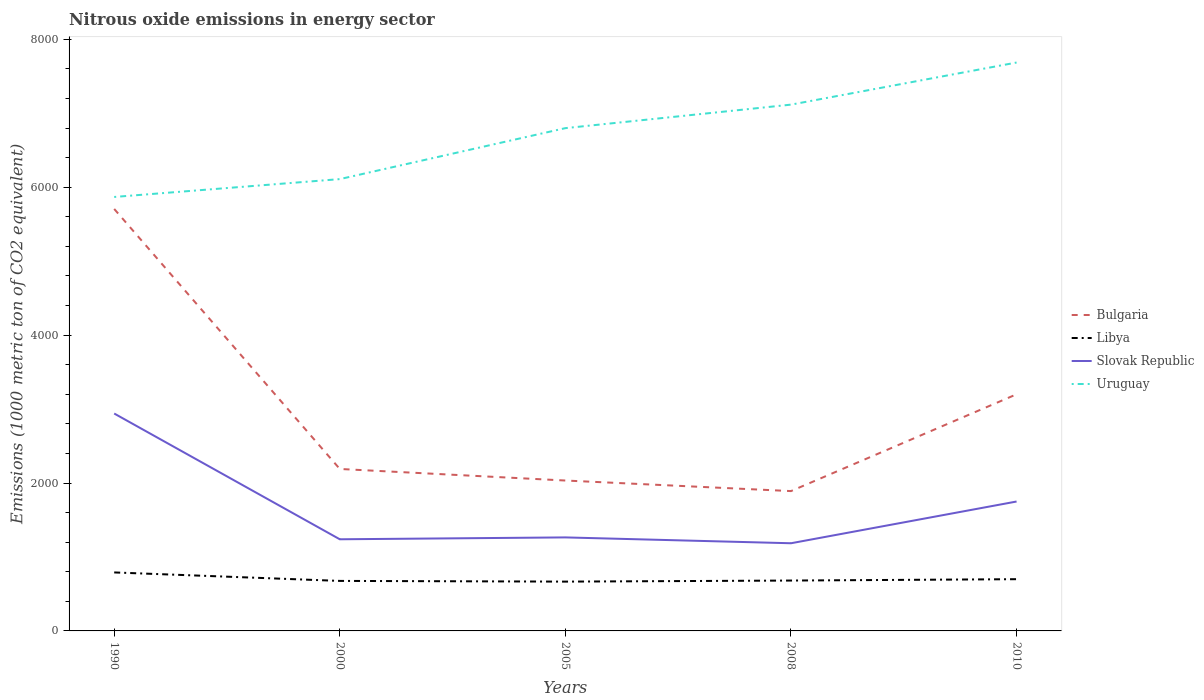How many different coloured lines are there?
Your answer should be compact. 4. Is the number of lines equal to the number of legend labels?
Your answer should be very brief. Yes. Across all years, what is the maximum amount of nitrous oxide emitted in Slovak Republic?
Keep it short and to the point. 1185.5. In which year was the amount of nitrous oxide emitted in Libya maximum?
Provide a succinct answer. 2005. What is the total amount of nitrous oxide emitted in Libya in the graph?
Your response must be concise. 109.7. What is the difference between the highest and the second highest amount of nitrous oxide emitted in Libya?
Make the answer very short. 124.1. What is the difference between the highest and the lowest amount of nitrous oxide emitted in Bulgaria?
Offer a very short reply. 2. Is the amount of nitrous oxide emitted in Uruguay strictly greater than the amount of nitrous oxide emitted in Libya over the years?
Give a very brief answer. No. How many years are there in the graph?
Provide a short and direct response. 5. Where does the legend appear in the graph?
Your answer should be compact. Center right. How many legend labels are there?
Ensure brevity in your answer.  4. What is the title of the graph?
Provide a succinct answer. Nitrous oxide emissions in energy sector. Does "Equatorial Guinea" appear as one of the legend labels in the graph?
Your answer should be very brief. No. What is the label or title of the Y-axis?
Make the answer very short. Emissions (1000 metric ton of CO2 equivalent). What is the Emissions (1000 metric ton of CO2 equivalent) of Bulgaria in 1990?
Make the answer very short. 5705.4. What is the Emissions (1000 metric ton of CO2 equivalent) of Libya in 1990?
Your answer should be very brief. 790.8. What is the Emissions (1000 metric ton of CO2 equivalent) in Slovak Republic in 1990?
Make the answer very short. 2939.5. What is the Emissions (1000 metric ton of CO2 equivalent) of Uruguay in 1990?
Offer a terse response. 5867.6. What is the Emissions (1000 metric ton of CO2 equivalent) in Bulgaria in 2000?
Give a very brief answer. 2189.9. What is the Emissions (1000 metric ton of CO2 equivalent) in Libya in 2000?
Provide a succinct answer. 676.2. What is the Emissions (1000 metric ton of CO2 equivalent) in Slovak Republic in 2000?
Your response must be concise. 1239.1. What is the Emissions (1000 metric ton of CO2 equivalent) in Uruguay in 2000?
Keep it short and to the point. 6109. What is the Emissions (1000 metric ton of CO2 equivalent) in Bulgaria in 2005?
Offer a terse response. 2033.5. What is the Emissions (1000 metric ton of CO2 equivalent) in Libya in 2005?
Offer a very short reply. 666.7. What is the Emissions (1000 metric ton of CO2 equivalent) of Slovak Republic in 2005?
Offer a very short reply. 1264.5. What is the Emissions (1000 metric ton of CO2 equivalent) of Uruguay in 2005?
Provide a short and direct response. 6798.2. What is the Emissions (1000 metric ton of CO2 equivalent) of Bulgaria in 2008?
Keep it short and to the point. 1890.6. What is the Emissions (1000 metric ton of CO2 equivalent) in Libya in 2008?
Provide a succinct answer. 681.1. What is the Emissions (1000 metric ton of CO2 equivalent) in Slovak Republic in 2008?
Offer a very short reply. 1185.5. What is the Emissions (1000 metric ton of CO2 equivalent) in Uruguay in 2008?
Keep it short and to the point. 7116. What is the Emissions (1000 metric ton of CO2 equivalent) of Bulgaria in 2010?
Make the answer very short. 3199.8. What is the Emissions (1000 metric ton of CO2 equivalent) of Libya in 2010?
Offer a terse response. 699.6. What is the Emissions (1000 metric ton of CO2 equivalent) in Slovak Republic in 2010?
Offer a very short reply. 1749.7. What is the Emissions (1000 metric ton of CO2 equivalent) in Uruguay in 2010?
Your answer should be very brief. 7685.3. Across all years, what is the maximum Emissions (1000 metric ton of CO2 equivalent) in Bulgaria?
Give a very brief answer. 5705.4. Across all years, what is the maximum Emissions (1000 metric ton of CO2 equivalent) in Libya?
Your answer should be compact. 790.8. Across all years, what is the maximum Emissions (1000 metric ton of CO2 equivalent) of Slovak Republic?
Keep it short and to the point. 2939.5. Across all years, what is the maximum Emissions (1000 metric ton of CO2 equivalent) of Uruguay?
Keep it short and to the point. 7685.3. Across all years, what is the minimum Emissions (1000 metric ton of CO2 equivalent) in Bulgaria?
Offer a very short reply. 1890.6. Across all years, what is the minimum Emissions (1000 metric ton of CO2 equivalent) in Libya?
Offer a terse response. 666.7. Across all years, what is the minimum Emissions (1000 metric ton of CO2 equivalent) in Slovak Republic?
Your response must be concise. 1185.5. Across all years, what is the minimum Emissions (1000 metric ton of CO2 equivalent) of Uruguay?
Your response must be concise. 5867.6. What is the total Emissions (1000 metric ton of CO2 equivalent) in Bulgaria in the graph?
Ensure brevity in your answer.  1.50e+04. What is the total Emissions (1000 metric ton of CO2 equivalent) in Libya in the graph?
Your response must be concise. 3514.4. What is the total Emissions (1000 metric ton of CO2 equivalent) of Slovak Republic in the graph?
Give a very brief answer. 8378.3. What is the total Emissions (1000 metric ton of CO2 equivalent) in Uruguay in the graph?
Your answer should be compact. 3.36e+04. What is the difference between the Emissions (1000 metric ton of CO2 equivalent) in Bulgaria in 1990 and that in 2000?
Your answer should be compact. 3515.5. What is the difference between the Emissions (1000 metric ton of CO2 equivalent) in Libya in 1990 and that in 2000?
Your answer should be compact. 114.6. What is the difference between the Emissions (1000 metric ton of CO2 equivalent) in Slovak Republic in 1990 and that in 2000?
Keep it short and to the point. 1700.4. What is the difference between the Emissions (1000 metric ton of CO2 equivalent) in Uruguay in 1990 and that in 2000?
Make the answer very short. -241.4. What is the difference between the Emissions (1000 metric ton of CO2 equivalent) in Bulgaria in 1990 and that in 2005?
Provide a succinct answer. 3671.9. What is the difference between the Emissions (1000 metric ton of CO2 equivalent) in Libya in 1990 and that in 2005?
Offer a terse response. 124.1. What is the difference between the Emissions (1000 metric ton of CO2 equivalent) in Slovak Republic in 1990 and that in 2005?
Your answer should be compact. 1675. What is the difference between the Emissions (1000 metric ton of CO2 equivalent) in Uruguay in 1990 and that in 2005?
Offer a terse response. -930.6. What is the difference between the Emissions (1000 metric ton of CO2 equivalent) of Bulgaria in 1990 and that in 2008?
Keep it short and to the point. 3814.8. What is the difference between the Emissions (1000 metric ton of CO2 equivalent) in Libya in 1990 and that in 2008?
Offer a very short reply. 109.7. What is the difference between the Emissions (1000 metric ton of CO2 equivalent) of Slovak Republic in 1990 and that in 2008?
Ensure brevity in your answer.  1754. What is the difference between the Emissions (1000 metric ton of CO2 equivalent) of Uruguay in 1990 and that in 2008?
Your answer should be very brief. -1248.4. What is the difference between the Emissions (1000 metric ton of CO2 equivalent) in Bulgaria in 1990 and that in 2010?
Your response must be concise. 2505.6. What is the difference between the Emissions (1000 metric ton of CO2 equivalent) in Libya in 1990 and that in 2010?
Your response must be concise. 91.2. What is the difference between the Emissions (1000 metric ton of CO2 equivalent) in Slovak Republic in 1990 and that in 2010?
Offer a terse response. 1189.8. What is the difference between the Emissions (1000 metric ton of CO2 equivalent) in Uruguay in 1990 and that in 2010?
Your answer should be compact. -1817.7. What is the difference between the Emissions (1000 metric ton of CO2 equivalent) of Bulgaria in 2000 and that in 2005?
Offer a very short reply. 156.4. What is the difference between the Emissions (1000 metric ton of CO2 equivalent) of Slovak Republic in 2000 and that in 2005?
Offer a terse response. -25.4. What is the difference between the Emissions (1000 metric ton of CO2 equivalent) in Uruguay in 2000 and that in 2005?
Provide a short and direct response. -689.2. What is the difference between the Emissions (1000 metric ton of CO2 equivalent) in Bulgaria in 2000 and that in 2008?
Ensure brevity in your answer.  299.3. What is the difference between the Emissions (1000 metric ton of CO2 equivalent) of Slovak Republic in 2000 and that in 2008?
Keep it short and to the point. 53.6. What is the difference between the Emissions (1000 metric ton of CO2 equivalent) in Uruguay in 2000 and that in 2008?
Offer a terse response. -1007. What is the difference between the Emissions (1000 metric ton of CO2 equivalent) in Bulgaria in 2000 and that in 2010?
Offer a terse response. -1009.9. What is the difference between the Emissions (1000 metric ton of CO2 equivalent) in Libya in 2000 and that in 2010?
Keep it short and to the point. -23.4. What is the difference between the Emissions (1000 metric ton of CO2 equivalent) of Slovak Republic in 2000 and that in 2010?
Your answer should be compact. -510.6. What is the difference between the Emissions (1000 metric ton of CO2 equivalent) of Uruguay in 2000 and that in 2010?
Offer a very short reply. -1576.3. What is the difference between the Emissions (1000 metric ton of CO2 equivalent) of Bulgaria in 2005 and that in 2008?
Give a very brief answer. 142.9. What is the difference between the Emissions (1000 metric ton of CO2 equivalent) in Libya in 2005 and that in 2008?
Your answer should be compact. -14.4. What is the difference between the Emissions (1000 metric ton of CO2 equivalent) in Slovak Republic in 2005 and that in 2008?
Ensure brevity in your answer.  79. What is the difference between the Emissions (1000 metric ton of CO2 equivalent) in Uruguay in 2005 and that in 2008?
Your answer should be compact. -317.8. What is the difference between the Emissions (1000 metric ton of CO2 equivalent) of Bulgaria in 2005 and that in 2010?
Offer a terse response. -1166.3. What is the difference between the Emissions (1000 metric ton of CO2 equivalent) of Libya in 2005 and that in 2010?
Offer a terse response. -32.9. What is the difference between the Emissions (1000 metric ton of CO2 equivalent) of Slovak Republic in 2005 and that in 2010?
Your response must be concise. -485.2. What is the difference between the Emissions (1000 metric ton of CO2 equivalent) of Uruguay in 2005 and that in 2010?
Offer a terse response. -887.1. What is the difference between the Emissions (1000 metric ton of CO2 equivalent) in Bulgaria in 2008 and that in 2010?
Offer a terse response. -1309.2. What is the difference between the Emissions (1000 metric ton of CO2 equivalent) in Libya in 2008 and that in 2010?
Your answer should be compact. -18.5. What is the difference between the Emissions (1000 metric ton of CO2 equivalent) of Slovak Republic in 2008 and that in 2010?
Your answer should be very brief. -564.2. What is the difference between the Emissions (1000 metric ton of CO2 equivalent) in Uruguay in 2008 and that in 2010?
Provide a short and direct response. -569.3. What is the difference between the Emissions (1000 metric ton of CO2 equivalent) of Bulgaria in 1990 and the Emissions (1000 metric ton of CO2 equivalent) of Libya in 2000?
Offer a very short reply. 5029.2. What is the difference between the Emissions (1000 metric ton of CO2 equivalent) of Bulgaria in 1990 and the Emissions (1000 metric ton of CO2 equivalent) of Slovak Republic in 2000?
Keep it short and to the point. 4466.3. What is the difference between the Emissions (1000 metric ton of CO2 equivalent) in Bulgaria in 1990 and the Emissions (1000 metric ton of CO2 equivalent) in Uruguay in 2000?
Provide a succinct answer. -403.6. What is the difference between the Emissions (1000 metric ton of CO2 equivalent) in Libya in 1990 and the Emissions (1000 metric ton of CO2 equivalent) in Slovak Republic in 2000?
Your response must be concise. -448.3. What is the difference between the Emissions (1000 metric ton of CO2 equivalent) of Libya in 1990 and the Emissions (1000 metric ton of CO2 equivalent) of Uruguay in 2000?
Keep it short and to the point. -5318.2. What is the difference between the Emissions (1000 metric ton of CO2 equivalent) in Slovak Republic in 1990 and the Emissions (1000 metric ton of CO2 equivalent) in Uruguay in 2000?
Your response must be concise. -3169.5. What is the difference between the Emissions (1000 metric ton of CO2 equivalent) in Bulgaria in 1990 and the Emissions (1000 metric ton of CO2 equivalent) in Libya in 2005?
Offer a terse response. 5038.7. What is the difference between the Emissions (1000 metric ton of CO2 equivalent) of Bulgaria in 1990 and the Emissions (1000 metric ton of CO2 equivalent) of Slovak Republic in 2005?
Your answer should be compact. 4440.9. What is the difference between the Emissions (1000 metric ton of CO2 equivalent) of Bulgaria in 1990 and the Emissions (1000 metric ton of CO2 equivalent) of Uruguay in 2005?
Give a very brief answer. -1092.8. What is the difference between the Emissions (1000 metric ton of CO2 equivalent) in Libya in 1990 and the Emissions (1000 metric ton of CO2 equivalent) in Slovak Republic in 2005?
Your answer should be compact. -473.7. What is the difference between the Emissions (1000 metric ton of CO2 equivalent) of Libya in 1990 and the Emissions (1000 metric ton of CO2 equivalent) of Uruguay in 2005?
Give a very brief answer. -6007.4. What is the difference between the Emissions (1000 metric ton of CO2 equivalent) of Slovak Republic in 1990 and the Emissions (1000 metric ton of CO2 equivalent) of Uruguay in 2005?
Offer a terse response. -3858.7. What is the difference between the Emissions (1000 metric ton of CO2 equivalent) in Bulgaria in 1990 and the Emissions (1000 metric ton of CO2 equivalent) in Libya in 2008?
Make the answer very short. 5024.3. What is the difference between the Emissions (1000 metric ton of CO2 equivalent) in Bulgaria in 1990 and the Emissions (1000 metric ton of CO2 equivalent) in Slovak Republic in 2008?
Offer a terse response. 4519.9. What is the difference between the Emissions (1000 metric ton of CO2 equivalent) of Bulgaria in 1990 and the Emissions (1000 metric ton of CO2 equivalent) of Uruguay in 2008?
Your answer should be compact. -1410.6. What is the difference between the Emissions (1000 metric ton of CO2 equivalent) of Libya in 1990 and the Emissions (1000 metric ton of CO2 equivalent) of Slovak Republic in 2008?
Provide a succinct answer. -394.7. What is the difference between the Emissions (1000 metric ton of CO2 equivalent) in Libya in 1990 and the Emissions (1000 metric ton of CO2 equivalent) in Uruguay in 2008?
Provide a succinct answer. -6325.2. What is the difference between the Emissions (1000 metric ton of CO2 equivalent) of Slovak Republic in 1990 and the Emissions (1000 metric ton of CO2 equivalent) of Uruguay in 2008?
Your answer should be very brief. -4176.5. What is the difference between the Emissions (1000 metric ton of CO2 equivalent) of Bulgaria in 1990 and the Emissions (1000 metric ton of CO2 equivalent) of Libya in 2010?
Give a very brief answer. 5005.8. What is the difference between the Emissions (1000 metric ton of CO2 equivalent) in Bulgaria in 1990 and the Emissions (1000 metric ton of CO2 equivalent) in Slovak Republic in 2010?
Make the answer very short. 3955.7. What is the difference between the Emissions (1000 metric ton of CO2 equivalent) of Bulgaria in 1990 and the Emissions (1000 metric ton of CO2 equivalent) of Uruguay in 2010?
Offer a very short reply. -1979.9. What is the difference between the Emissions (1000 metric ton of CO2 equivalent) in Libya in 1990 and the Emissions (1000 metric ton of CO2 equivalent) in Slovak Republic in 2010?
Ensure brevity in your answer.  -958.9. What is the difference between the Emissions (1000 metric ton of CO2 equivalent) in Libya in 1990 and the Emissions (1000 metric ton of CO2 equivalent) in Uruguay in 2010?
Ensure brevity in your answer.  -6894.5. What is the difference between the Emissions (1000 metric ton of CO2 equivalent) of Slovak Republic in 1990 and the Emissions (1000 metric ton of CO2 equivalent) of Uruguay in 2010?
Make the answer very short. -4745.8. What is the difference between the Emissions (1000 metric ton of CO2 equivalent) of Bulgaria in 2000 and the Emissions (1000 metric ton of CO2 equivalent) of Libya in 2005?
Offer a terse response. 1523.2. What is the difference between the Emissions (1000 metric ton of CO2 equivalent) of Bulgaria in 2000 and the Emissions (1000 metric ton of CO2 equivalent) of Slovak Republic in 2005?
Your response must be concise. 925.4. What is the difference between the Emissions (1000 metric ton of CO2 equivalent) in Bulgaria in 2000 and the Emissions (1000 metric ton of CO2 equivalent) in Uruguay in 2005?
Offer a very short reply. -4608.3. What is the difference between the Emissions (1000 metric ton of CO2 equivalent) of Libya in 2000 and the Emissions (1000 metric ton of CO2 equivalent) of Slovak Republic in 2005?
Give a very brief answer. -588.3. What is the difference between the Emissions (1000 metric ton of CO2 equivalent) of Libya in 2000 and the Emissions (1000 metric ton of CO2 equivalent) of Uruguay in 2005?
Keep it short and to the point. -6122. What is the difference between the Emissions (1000 metric ton of CO2 equivalent) in Slovak Republic in 2000 and the Emissions (1000 metric ton of CO2 equivalent) in Uruguay in 2005?
Give a very brief answer. -5559.1. What is the difference between the Emissions (1000 metric ton of CO2 equivalent) of Bulgaria in 2000 and the Emissions (1000 metric ton of CO2 equivalent) of Libya in 2008?
Provide a succinct answer. 1508.8. What is the difference between the Emissions (1000 metric ton of CO2 equivalent) of Bulgaria in 2000 and the Emissions (1000 metric ton of CO2 equivalent) of Slovak Republic in 2008?
Keep it short and to the point. 1004.4. What is the difference between the Emissions (1000 metric ton of CO2 equivalent) of Bulgaria in 2000 and the Emissions (1000 metric ton of CO2 equivalent) of Uruguay in 2008?
Provide a short and direct response. -4926.1. What is the difference between the Emissions (1000 metric ton of CO2 equivalent) of Libya in 2000 and the Emissions (1000 metric ton of CO2 equivalent) of Slovak Republic in 2008?
Make the answer very short. -509.3. What is the difference between the Emissions (1000 metric ton of CO2 equivalent) in Libya in 2000 and the Emissions (1000 metric ton of CO2 equivalent) in Uruguay in 2008?
Offer a very short reply. -6439.8. What is the difference between the Emissions (1000 metric ton of CO2 equivalent) in Slovak Republic in 2000 and the Emissions (1000 metric ton of CO2 equivalent) in Uruguay in 2008?
Keep it short and to the point. -5876.9. What is the difference between the Emissions (1000 metric ton of CO2 equivalent) in Bulgaria in 2000 and the Emissions (1000 metric ton of CO2 equivalent) in Libya in 2010?
Provide a succinct answer. 1490.3. What is the difference between the Emissions (1000 metric ton of CO2 equivalent) of Bulgaria in 2000 and the Emissions (1000 metric ton of CO2 equivalent) of Slovak Republic in 2010?
Provide a succinct answer. 440.2. What is the difference between the Emissions (1000 metric ton of CO2 equivalent) in Bulgaria in 2000 and the Emissions (1000 metric ton of CO2 equivalent) in Uruguay in 2010?
Provide a short and direct response. -5495.4. What is the difference between the Emissions (1000 metric ton of CO2 equivalent) in Libya in 2000 and the Emissions (1000 metric ton of CO2 equivalent) in Slovak Republic in 2010?
Your answer should be very brief. -1073.5. What is the difference between the Emissions (1000 metric ton of CO2 equivalent) in Libya in 2000 and the Emissions (1000 metric ton of CO2 equivalent) in Uruguay in 2010?
Your response must be concise. -7009.1. What is the difference between the Emissions (1000 metric ton of CO2 equivalent) in Slovak Republic in 2000 and the Emissions (1000 metric ton of CO2 equivalent) in Uruguay in 2010?
Give a very brief answer. -6446.2. What is the difference between the Emissions (1000 metric ton of CO2 equivalent) in Bulgaria in 2005 and the Emissions (1000 metric ton of CO2 equivalent) in Libya in 2008?
Your answer should be very brief. 1352.4. What is the difference between the Emissions (1000 metric ton of CO2 equivalent) of Bulgaria in 2005 and the Emissions (1000 metric ton of CO2 equivalent) of Slovak Republic in 2008?
Your answer should be compact. 848. What is the difference between the Emissions (1000 metric ton of CO2 equivalent) of Bulgaria in 2005 and the Emissions (1000 metric ton of CO2 equivalent) of Uruguay in 2008?
Ensure brevity in your answer.  -5082.5. What is the difference between the Emissions (1000 metric ton of CO2 equivalent) of Libya in 2005 and the Emissions (1000 metric ton of CO2 equivalent) of Slovak Republic in 2008?
Make the answer very short. -518.8. What is the difference between the Emissions (1000 metric ton of CO2 equivalent) of Libya in 2005 and the Emissions (1000 metric ton of CO2 equivalent) of Uruguay in 2008?
Provide a succinct answer. -6449.3. What is the difference between the Emissions (1000 metric ton of CO2 equivalent) in Slovak Republic in 2005 and the Emissions (1000 metric ton of CO2 equivalent) in Uruguay in 2008?
Give a very brief answer. -5851.5. What is the difference between the Emissions (1000 metric ton of CO2 equivalent) of Bulgaria in 2005 and the Emissions (1000 metric ton of CO2 equivalent) of Libya in 2010?
Keep it short and to the point. 1333.9. What is the difference between the Emissions (1000 metric ton of CO2 equivalent) of Bulgaria in 2005 and the Emissions (1000 metric ton of CO2 equivalent) of Slovak Republic in 2010?
Provide a succinct answer. 283.8. What is the difference between the Emissions (1000 metric ton of CO2 equivalent) in Bulgaria in 2005 and the Emissions (1000 metric ton of CO2 equivalent) in Uruguay in 2010?
Your response must be concise. -5651.8. What is the difference between the Emissions (1000 metric ton of CO2 equivalent) in Libya in 2005 and the Emissions (1000 metric ton of CO2 equivalent) in Slovak Republic in 2010?
Offer a very short reply. -1083. What is the difference between the Emissions (1000 metric ton of CO2 equivalent) in Libya in 2005 and the Emissions (1000 metric ton of CO2 equivalent) in Uruguay in 2010?
Provide a short and direct response. -7018.6. What is the difference between the Emissions (1000 metric ton of CO2 equivalent) of Slovak Republic in 2005 and the Emissions (1000 metric ton of CO2 equivalent) of Uruguay in 2010?
Offer a terse response. -6420.8. What is the difference between the Emissions (1000 metric ton of CO2 equivalent) of Bulgaria in 2008 and the Emissions (1000 metric ton of CO2 equivalent) of Libya in 2010?
Offer a terse response. 1191. What is the difference between the Emissions (1000 metric ton of CO2 equivalent) in Bulgaria in 2008 and the Emissions (1000 metric ton of CO2 equivalent) in Slovak Republic in 2010?
Your answer should be compact. 140.9. What is the difference between the Emissions (1000 metric ton of CO2 equivalent) in Bulgaria in 2008 and the Emissions (1000 metric ton of CO2 equivalent) in Uruguay in 2010?
Ensure brevity in your answer.  -5794.7. What is the difference between the Emissions (1000 metric ton of CO2 equivalent) of Libya in 2008 and the Emissions (1000 metric ton of CO2 equivalent) of Slovak Republic in 2010?
Provide a short and direct response. -1068.6. What is the difference between the Emissions (1000 metric ton of CO2 equivalent) of Libya in 2008 and the Emissions (1000 metric ton of CO2 equivalent) of Uruguay in 2010?
Your answer should be compact. -7004.2. What is the difference between the Emissions (1000 metric ton of CO2 equivalent) in Slovak Republic in 2008 and the Emissions (1000 metric ton of CO2 equivalent) in Uruguay in 2010?
Your response must be concise. -6499.8. What is the average Emissions (1000 metric ton of CO2 equivalent) in Bulgaria per year?
Ensure brevity in your answer.  3003.84. What is the average Emissions (1000 metric ton of CO2 equivalent) in Libya per year?
Offer a terse response. 702.88. What is the average Emissions (1000 metric ton of CO2 equivalent) in Slovak Republic per year?
Offer a terse response. 1675.66. What is the average Emissions (1000 metric ton of CO2 equivalent) of Uruguay per year?
Your answer should be very brief. 6715.22. In the year 1990, what is the difference between the Emissions (1000 metric ton of CO2 equivalent) of Bulgaria and Emissions (1000 metric ton of CO2 equivalent) of Libya?
Your answer should be compact. 4914.6. In the year 1990, what is the difference between the Emissions (1000 metric ton of CO2 equivalent) of Bulgaria and Emissions (1000 metric ton of CO2 equivalent) of Slovak Republic?
Make the answer very short. 2765.9. In the year 1990, what is the difference between the Emissions (1000 metric ton of CO2 equivalent) of Bulgaria and Emissions (1000 metric ton of CO2 equivalent) of Uruguay?
Offer a very short reply. -162.2. In the year 1990, what is the difference between the Emissions (1000 metric ton of CO2 equivalent) in Libya and Emissions (1000 metric ton of CO2 equivalent) in Slovak Republic?
Offer a terse response. -2148.7. In the year 1990, what is the difference between the Emissions (1000 metric ton of CO2 equivalent) in Libya and Emissions (1000 metric ton of CO2 equivalent) in Uruguay?
Your answer should be very brief. -5076.8. In the year 1990, what is the difference between the Emissions (1000 metric ton of CO2 equivalent) in Slovak Republic and Emissions (1000 metric ton of CO2 equivalent) in Uruguay?
Ensure brevity in your answer.  -2928.1. In the year 2000, what is the difference between the Emissions (1000 metric ton of CO2 equivalent) of Bulgaria and Emissions (1000 metric ton of CO2 equivalent) of Libya?
Keep it short and to the point. 1513.7. In the year 2000, what is the difference between the Emissions (1000 metric ton of CO2 equivalent) in Bulgaria and Emissions (1000 metric ton of CO2 equivalent) in Slovak Republic?
Your answer should be compact. 950.8. In the year 2000, what is the difference between the Emissions (1000 metric ton of CO2 equivalent) in Bulgaria and Emissions (1000 metric ton of CO2 equivalent) in Uruguay?
Provide a succinct answer. -3919.1. In the year 2000, what is the difference between the Emissions (1000 metric ton of CO2 equivalent) of Libya and Emissions (1000 metric ton of CO2 equivalent) of Slovak Republic?
Give a very brief answer. -562.9. In the year 2000, what is the difference between the Emissions (1000 metric ton of CO2 equivalent) of Libya and Emissions (1000 metric ton of CO2 equivalent) of Uruguay?
Your response must be concise. -5432.8. In the year 2000, what is the difference between the Emissions (1000 metric ton of CO2 equivalent) in Slovak Republic and Emissions (1000 metric ton of CO2 equivalent) in Uruguay?
Offer a terse response. -4869.9. In the year 2005, what is the difference between the Emissions (1000 metric ton of CO2 equivalent) in Bulgaria and Emissions (1000 metric ton of CO2 equivalent) in Libya?
Your answer should be very brief. 1366.8. In the year 2005, what is the difference between the Emissions (1000 metric ton of CO2 equivalent) of Bulgaria and Emissions (1000 metric ton of CO2 equivalent) of Slovak Republic?
Ensure brevity in your answer.  769. In the year 2005, what is the difference between the Emissions (1000 metric ton of CO2 equivalent) in Bulgaria and Emissions (1000 metric ton of CO2 equivalent) in Uruguay?
Provide a succinct answer. -4764.7. In the year 2005, what is the difference between the Emissions (1000 metric ton of CO2 equivalent) in Libya and Emissions (1000 metric ton of CO2 equivalent) in Slovak Republic?
Your response must be concise. -597.8. In the year 2005, what is the difference between the Emissions (1000 metric ton of CO2 equivalent) of Libya and Emissions (1000 metric ton of CO2 equivalent) of Uruguay?
Offer a very short reply. -6131.5. In the year 2005, what is the difference between the Emissions (1000 metric ton of CO2 equivalent) of Slovak Republic and Emissions (1000 metric ton of CO2 equivalent) of Uruguay?
Provide a succinct answer. -5533.7. In the year 2008, what is the difference between the Emissions (1000 metric ton of CO2 equivalent) in Bulgaria and Emissions (1000 metric ton of CO2 equivalent) in Libya?
Give a very brief answer. 1209.5. In the year 2008, what is the difference between the Emissions (1000 metric ton of CO2 equivalent) of Bulgaria and Emissions (1000 metric ton of CO2 equivalent) of Slovak Republic?
Provide a short and direct response. 705.1. In the year 2008, what is the difference between the Emissions (1000 metric ton of CO2 equivalent) of Bulgaria and Emissions (1000 metric ton of CO2 equivalent) of Uruguay?
Provide a short and direct response. -5225.4. In the year 2008, what is the difference between the Emissions (1000 metric ton of CO2 equivalent) of Libya and Emissions (1000 metric ton of CO2 equivalent) of Slovak Republic?
Provide a short and direct response. -504.4. In the year 2008, what is the difference between the Emissions (1000 metric ton of CO2 equivalent) in Libya and Emissions (1000 metric ton of CO2 equivalent) in Uruguay?
Your answer should be compact. -6434.9. In the year 2008, what is the difference between the Emissions (1000 metric ton of CO2 equivalent) of Slovak Republic and Emissions (1000 metric ton of CO2 equivalent) of Uruguay?
Make the answer very short. -5930.5. In the year 2010, what is the difference between the Emissions (1000 metric ton of CO2 equivalent) of Bulgaria and Emissions (1000 metric ton of CO2 equivalent) of Libya?
Your response must be concise. 2500.2. In the year 2010, what is the difference between the Emissions (1000 metric ton of CO2 equivalent) in Bulgaria and Emissions (1000 metric ton of CO2 equivalent) in Slovak Republic?
Provide a succinct answer. 1450.1. In the year 2010, what is the difference between the Emissions (1000 metric ton of CO2 equivalent) in Bulgaria and Emissions (1000 metric ton of CO2 equivalent) in Uruguay?
Your answer should be very brief. -4485.5. In the year 2010, what is the difference between the Emissions (1000 metric ton of CO2 equivalent) in Libya and Emissions (1000 metric ton of CO2 equivalent) in Slovak Republic?
Ensure brevity in your answer.  -1050.1. In the year 2010, what is the difference between the Emissions (1000 metric ton of CO2 equivalent) in Libya and Emissions (1000 metric ton of CO2 equivalent) in Uruguay?
Offer a very short reply. -6985.7. In the year 2010, what is the difference between the Emissions (1000 metric ton of CO2 equivalent) in Slovak Republic and Emissions (1000 metric ton of CO2 equivalent) in Uruguay?
Offer a very short reply. -5935.6. What is the ratio of the Emissions (1000 metric ton of CO2 equivalent) in Bulgaria in 1990 to that in 2000?
Your response must be concise. 2.61. What is the ratio of the Emissions (1000 metric ton of CO2 equivalent) of Libya in 1990 to that in 2000?
Your answer should be very brief. 1.17. What is the ratio of the Emissions (1000 metric ton of CO2 equivalent) in Slovak Republic in 1990 to that in 2000?
Your response must be concise. 2.37. What is the ratio of the Emissions (1000 metric ton of CO2 equivalent) in Uruguay in 1990 to that in 2000?
Your answer should be compact. 0.96. What is the ratio of the Emissions (1000 metric ton of CO2 equivalent) of Bulgaria in 1990 to that in 2005?
Offer a terse response. 2.81. What is the ratio of the Emissions (1000 metric ton of CO2 equivalent) of Libya in 1990 to that in 2005?
Offer a terse response. 1.19. What is the ratio of the Emissions (1000 metric ton of CO2 equivalent) of Slovak Republic in 1990 to that in 2005?
Provide a short and direct response. 2.32. What is the ratio of the Emissions (1000 metric ton of CO2 equivalent) of Uruguay in 1990 to that in 2005?
Give a very brief answer. 0.86. What is the ratio of the Emissions (1000 metric ton of CO2 equivalent) of Bulgaria in 1990 to that in 2008?
Your answer should be very brief. 3.02. What is the ratio of the Emissions (1000 metric ton of CO2 equivalent) in Libya in 1990 to that in 2008?
Keep it short and to the point. 1.16. What is the ratio of the Emissions (1000 metric ton of CO2 equivalent) of Slovak Republic in 1990 to that in 2008?
Offer a terse response. 2.48. What is the ratio of the Emissions (1000 metric ton of CO2 equivalent) of Uruguay in 1990 to that in 2008?
Your answer should be very brief. 0.82. What is the ratio of the Emissions (1000 metric ton of CO2 equivalent) in Bulgaria in 1990 to that in 2010?
Ensure brevity in your answer.  1.78. What is the ratio of the Emissions (1000 metric ton of CO2 equivalent) of Libya in 1990 to that in 2010?
Provide a succinct answer. 1.13. What is the ratio of the Emissions (1000 metric ton of CO2 equivalent) of Slovak Republic in 1990 to that in 2010?
Your answer should be compact. 1.68. What is the ratio of the Emissions (1000 metric ton of CO2 equivalent) of Uruguay in 1990 to that in 2010?
Keep it short and to the point. 0.76. What is the ratio of the Emissions (1000 metric ton of CO2 equivalent) in Bulgaria in 2000 to that in 2005?
Make the answer very short. 1.08. What is the ratio of the Emissions (1000 metric ton of CO2 equivalent) of Libya in 2000 to that in 2005?
Your response must be concise. 1.01. What is the ratio of the Emissions (1000 metric ton of CO2 equivalent) of Slovak Republic in 2000 to that in 2005?
Provide a short and direct response. 0.98. What is the ratio of the Emissions (1000 metric ton of CO2 equivalent) of Uruguay in 2000 to that in 2005?
Provide a short and direct response. 0.9. What is the ratio of the Emissions (1000 metric ton of CO2 equivalent) of Bulgaria in 2000 to that in 2008?
Offer a very short reply. 1.16. What is the ratio of the Emissions (1000 metric ton of CO2 equivalent) of Libya in 2000 to that in 2008?
Offer a very short reply. 0.99. What is the ratio of the Emissions (1000 metric ton of CO2 equivalent) in Slovak Republic in 2000 to that in 2008?
Give a very brief answer. 1.05. What is the ratio of the Emissions (1000 metric ton of CO2 equivalent) of Uruguay in 2000 to that in 2008?
Provide a succinct answer. 0.86. What is the ratio of the Emissions (1000 metric ton of CO2 equivalent) of Bulgaria in 2000 to that in 2010?
Make the answer very short. 0.68. What is the ratio of the Emissions (1000 metric ton of CO2 equivalent) in Libya in 2000 to that in 2010?
Make the answer very short. 0.97. What is the ratio of the Emissions (1000 metric ton of CO2 equivalent) of Slovak Republic in 2000 to that in 2010?
Give a very brief answer. 0.71. What is the ratio of the Emissions (1000 metric ton of CO2 equivalent) of Uruguay in 2000 to that in 2010?
Offer a very short reply. 0.79. What is the ratio of the Emissions (1000 metric ton of CO2 equivalent) of Bulgaria in 2005 to that in 2008?
Ensure brevity in your answer.  1.08. What is the ratio of the Emissions (1000 metric ton of CO2 equivalent) of Libya in 2005 to that in 2008?
Give a very brief answer. 0.98. What is the ratio of the Emissions (1000 metric ton of CO2 equivalent) in Slovak Republic in 2005 to that in 2008?
Keep it short and to the point. 1.07. What is the ratio of the Emissions (1000 metric ton of CO2 equivalent) in Uruguay in 2005 to that in 2008?
Keep it short and to the point. 0.96. What is the ratio of the Emissions (1000 metric ton of CO2 equivalent) of Bulgaria in 2005 to that in 2010?
Provide a short and direct response. 0.64. What is the ratio of the Emissions (1000 metric ton of CO2 equivalent) in Libya in 2005 to that in 2010?
Make the answer very short. 0.95. What is the ratio of the Emissions (1000 metric ton of CO2 equivalent) of Slovak Republic in 2005 to that in 2010?
Your answer should be compact. 0.72. What is the ratio of the Emissions (1000 metric ton of CO2 equivalent) in Uruguay in 2005 to that in 2010?
Provide a short and direct response. 0.88. What is the ratio of the Emissions (1000 metric ton of CO2 equivalent) of Bulgaria in 2008 to that in 2010?
Offer a terse response. 0.59. What is the ratio of the Emissions (1000 metric ton of CO2 equivalent) of Libya in 2008 to that in 2010?
Keep it short and to the point. 0.97. What is the ratio of the Emissions (1000 metric ton of CO2 equivalent) of Slovak Republic in 2008 to that in 2010?
Your response must be concise. 0.68. What is the ratio of the Emissions (1000 metric ton of CO2 equivalent) in Uruguay in 2008 to that in 2010?
Keep it short and to the point. 0.93. What is the difference between the highest and the second highest Emissions (1000 metric ton of CO2 equivalent) in Bulgaria?
Make the answer very short. 2505.6. What is the difference between the highest and the second highest Emissions (1000 metric ton of CO2 equivalent) in Libya?
Your response must be concise. 91.2. What is the difference between the highest and the second highest Emissions (1000 metric ton of CO2 equivalent) in Slovak Republic?
Ensure brevity in your answer.  1189.8. What is the difference between the highest and the second highest Emissions (1000 metric ton of CO2 equivalent) in Uruguay?
Keep it short and to the point. 569.3. What is the difference between the highest and the lowest Emissions (1000 metric ton of CO2 equivalent) in Bulgaria?
Your answer should be compact. 3814.8. What is the difference between the highest and the lowest Emissions (1000 metric ton of CO2 equivalent) of Libya?
Give a very brief answer. 124.1. What is the difference between the highest and the lowest Emissions (1000 metric ton of CO2 equivalent) in Slovak Republic?
Your answer should be compact. 1754. What is the difference between the highest and the lowest Emissions (1000 metric ton of CO2 equivalent) of Uruguay?
Provide a succinct answer. 1817.7. 